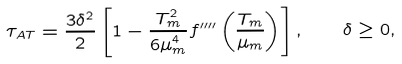Convert formula to latex. <formula><loc_0><loc_0><loc_500><loc_500>\tau _ { A T } = \frac { 3 \delta ^ { 2 } } { 2 } \left [ 1 - \frac { T _ { m } ^ { 2 } } { 6 \mu _ { m } ^ { 4 } } f ^ { \prime \prime \prime \prime } \left ( \frac { T _ { m } } { \mu _ { m } } \right ) \right ] , \quad \delta \geq 0 ,</formula> 